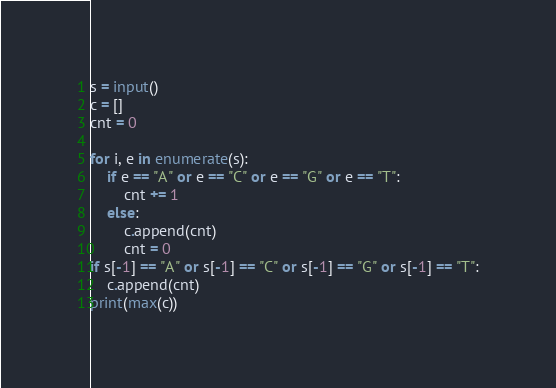Convert code to text. <code><loc_0><loc_0><loc_500><loc_500><_Python_>s = input()
c = []
cnt = 0

for i, e in enumerate(s):
    if e == "A" or e == "C" or e == "G" or e == "T":
        cnt += 1
    else:
        c.append(cnt)
        cnt = 0
if s[-1] == "A" or s[-1] == "C" or s[-1] == "G" or s[-1] == "T":
    c.append(cnt)
print(max(c))
</code> 